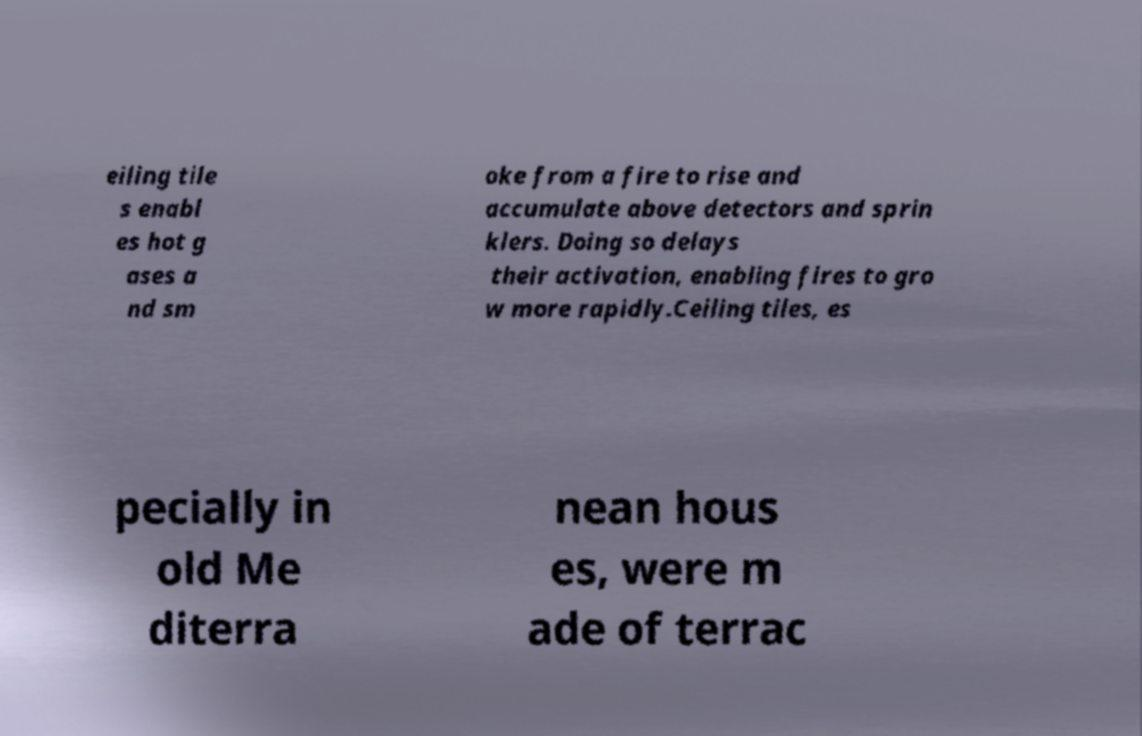What messages or text are displayed in this image? I need them in a readable, typed format. eiling tile s enabl es hot g ases a nd sm oke from a fire to rise and accumulate above detectors and sprin klers. Doing so delays their activation, enabling fires to gro w more rapidly.Ceiling tiles, es pecially in old Me diterra nean hous es, were m ade of terrac 